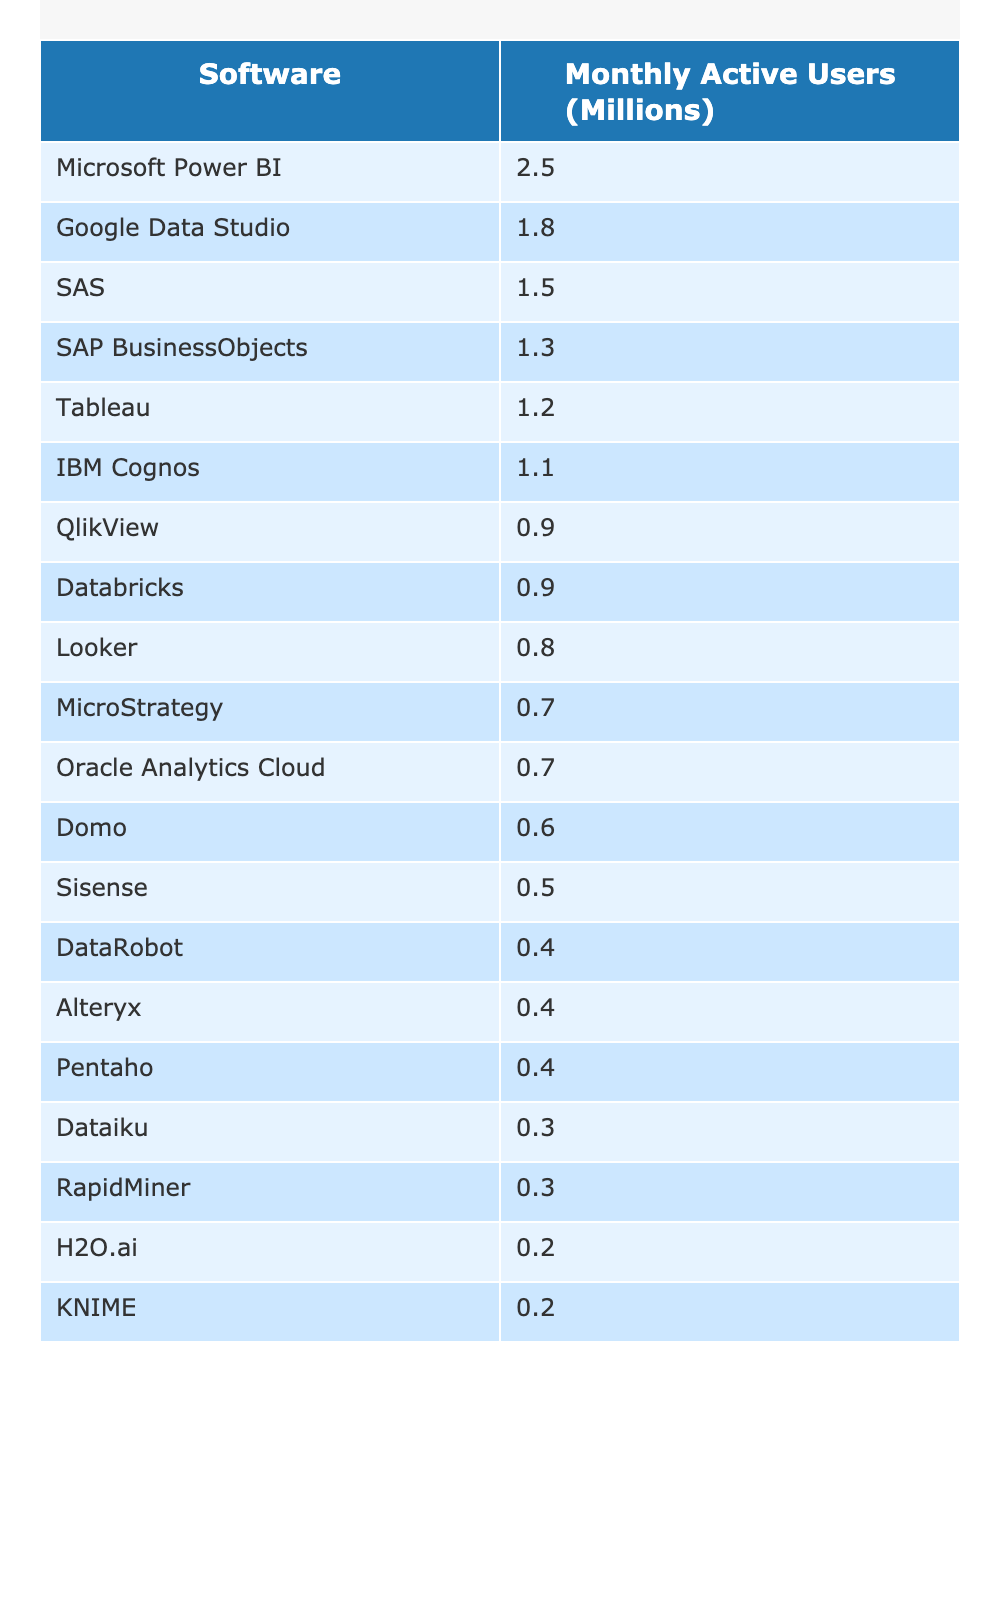What is the Monthly Active User count for Microsoft Power BI? Referring to the table, Microsoft Power BI has a Monthly Active User count of 2.5 million.
Answer: 2.5 million Which software platform has the least Monthly Active Users? By examining the table, Sisense has the lowest number of Monthly Active Users at 0.5 million.
Answer: Sisense What is the combined Monthly Active User count of Tableau and SAS? Tableau has 1.2 million and SAS has 1.5 million. Adding these together gives 1.2 + 1.5 = 2.7 million.
Answer: 2.7 million Is the Monthly Active User count for DataRobot greater than the count for Alteryx? DataRobot has 0.4 million users, while Alteryx has 0.4 million users as well. Since they are equal, the statement is false.
Answer: No How many platforms have Monthly Active Users above 1 million? Referring to the table, the platforms with over 1 million users are Tableau, Microsoft Power BI, SAS, Google Data Studio, and SAP BusinessObjects, totaling 5 platforms.
Answer: 5 platforms If we consider the average Monthly Active Users for the platforms listed, what would that value be? There are 20 entries in total. Adding the Monthly Active User counts yields 11.65 million, and dividing by 20 gives an average of 0.5825 million.
Answer: 0.5825 million What percentage of the total Monthly Active Users does Microsoft Power BI represent? The total Monthly Active Users from the table is 11.65 million and Microsoft Power BI has 2.5 million. Dividing gives 2.5 / 11.65 ≈ 0.2144, or about 21.44%.
Answer: 21.44% Which software has more Monthly Active Users, Looker or Databricks? Looker has 0.8 million active users, while Databricks has 0.9 million users. Comparing these figures, Databricks has more users.
Answer: Databricks What is the difference between the Monthly Active Users of Google Data Studio and IBM Cognos? Google Data Studio has 1.8 million users, and IBM Cognos has 1.1 million. The difference is 1.8 - 1.1 = 0.7 million.
Answer: 0.7 million Is the total of users for the three platforms with the highest counts greater than 5 million? The top three platforms are Microsoft Power BI (2.5 million), Google Data Studio (1.8 million), and SAS (1.5 million). Their total is 2.5 + 1.8 + 1.5 = 5.8 million, which is greater than 5 million.
Answer: Yes 